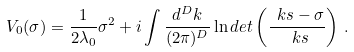<formula> <loc_0><loc_0><loc_500><loc_500>V _ { 0 } ( \sigma ) = \frac { 1 } { 2 \lambda _ { 0 } } \sigma ^ { 2 } + i \int \frac { d ^ { D } k } { ( 2 \pi ) ^ { D } } \ln d e t \left ( \frac { \ k s - \sigma } { \ k s } \right ) \, .</formula> 